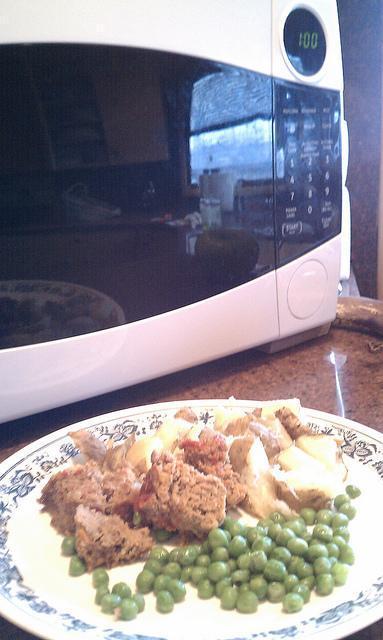How many different foods are on the plate?
Give a very brief answer. 3. 